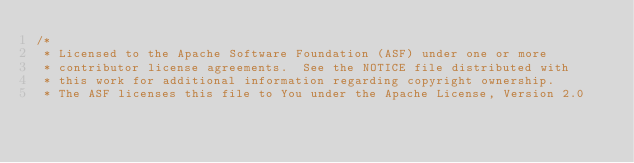Convert code to text. <code><loc_0><loc_0><loc_500><loc_500><_Scala_>/*
 * Licensed to the Apache Software Foundation (ASF) under one or more
 * contributor license agreements.  See the NOTICE file distributed with
 * this work for additional information regarding copyright ownership.
 * The ASF licenses this file to You under the Apache License, Version 2.0</code> 